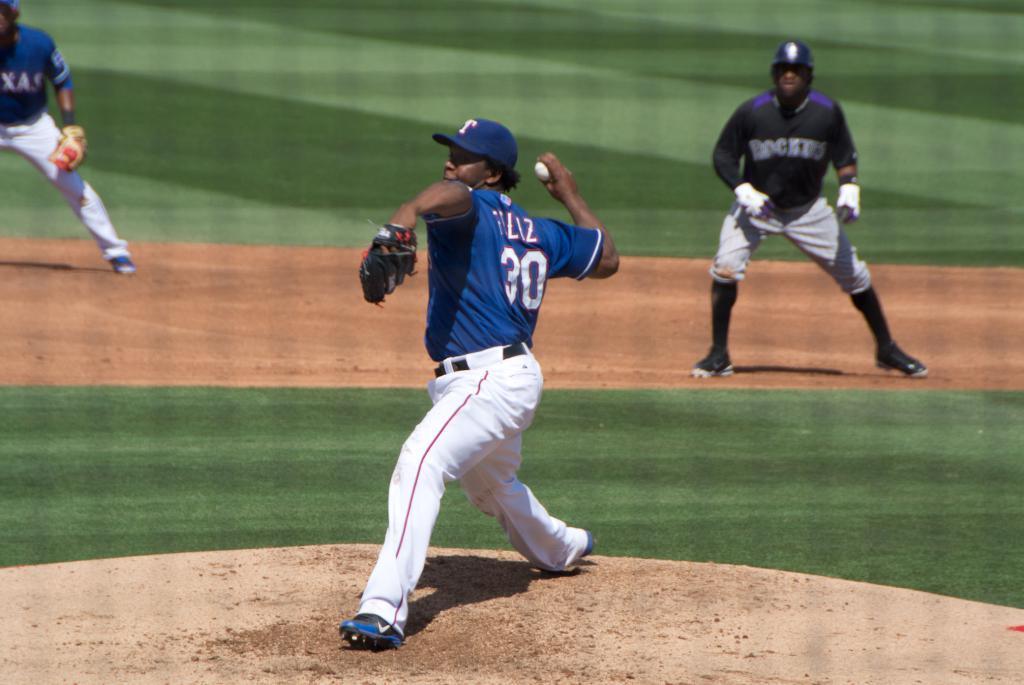Could you give a brief overview of what you see in this image? Here in the middle we can see a person standing in a ground, he is throwing a ball present in his hand and he is wearing a cap and gloves on him and behind him also we can see other people standing in the ground with helmets and gloves on them over there. 